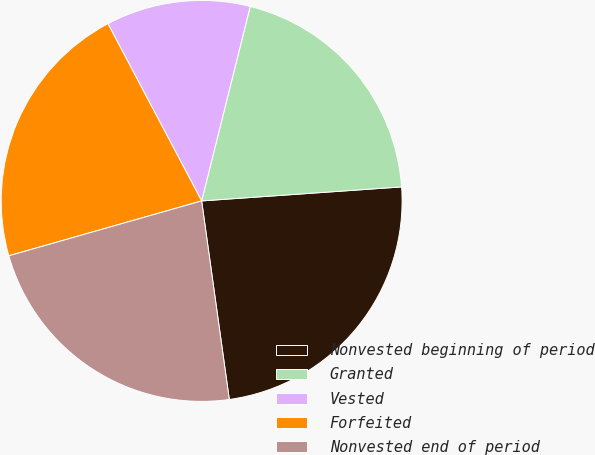Convert chart. <chart><loc_0><loc_0><loc_500><loc_500><pie_chart><fcel>Nonvested beginning of period<fcel>Granted<fcel>Vested<fcel>Forfeited<fcel>Nonvested end of period<nl><fcel>23.91%<fcel>19.99%<fcel>11.64%<fcel>21.67%<fcel>22.79%<nl></chart> 